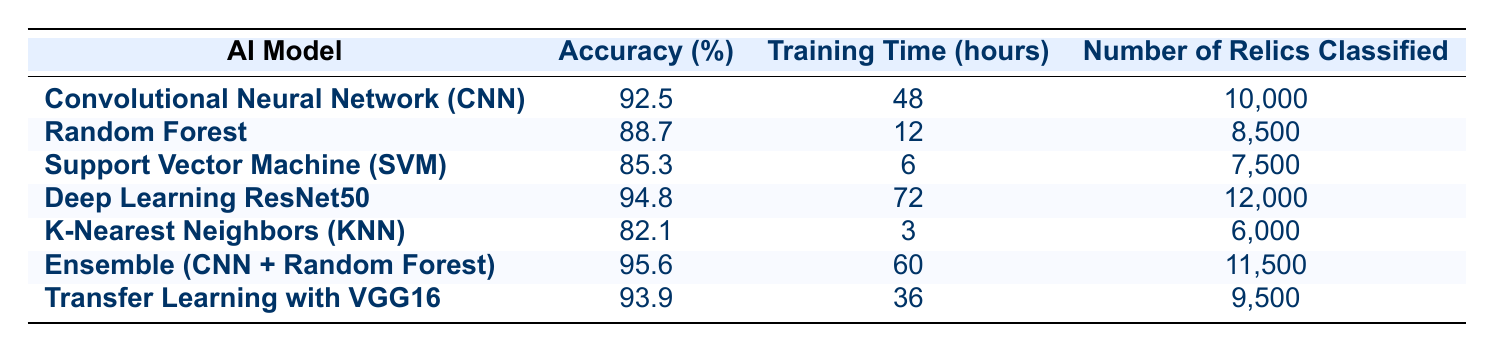What is the highest accuracy achieved by an AI model in this comparison? The table lists the accuracies of each AI model, and the maximum accuracy can be found by looking through the "Accuracy (%)" column. Deep Learning ResNet50 has an accuracy of 94.8%, and Ensemble (CNN + Random Forest) surpasses it with an accuracy of 95.6%.
Answer: 95.6 Which AI model took the least amount of training time? To find the model that required the least training time, we compare the "Training Time (hours)" column. The K-Nearest Neighbors (KNN) model has the least at 3 hours.
Answer: K-Nearest Neighbors (KNN) Is the accuracy of the Support Vector Machine (SVM) greater than 90%? By examining the "Accuracy (%)" column for SVM, we see that it has an accuracy of 85.3%. Since 85.3% is less than 90%, the statement is false.
Answer: No What is the average training time of all the AI models listed? To calculate the average training time, we first sum the training times of all models: 48 + 12 + 6 + 72 + 3 + 60 + 36 = 237 hours. Then, we divide by the number of models (7): 237 / 7 = 33.86 hours, which can be rounded to 33.9 hours.
Answer: 33.9 How many relics were classified by the Ensemble model compared to the CNN model? The "Number of Relics Classified" column shows that the Ensemble model classified 11,500 relics while the CNN model classified 10,000 relics. The difference is calculated as 11,500 - 10,000 = 1,500 relics more for the Ensemble model.
Answer: 1,500 more Which model had an accuracy lower than the average accuracy of all models? First, we need to calculate the average accuracy: (92.5 + 88.7 + 85.3 + 94.8 + 82.1 + 95.6 + 93.9) / 7 = 90.4%. Looking at the "Accuracy (%)" column reveals that K-Nearest Neighbors (KNN) at 82.1% and Support Vector Machine (SVM) at 85.3% are both below 90.4%.
Answer: K-Nearest Neighbors (KNN) and Support Vector Machine (SVM) 